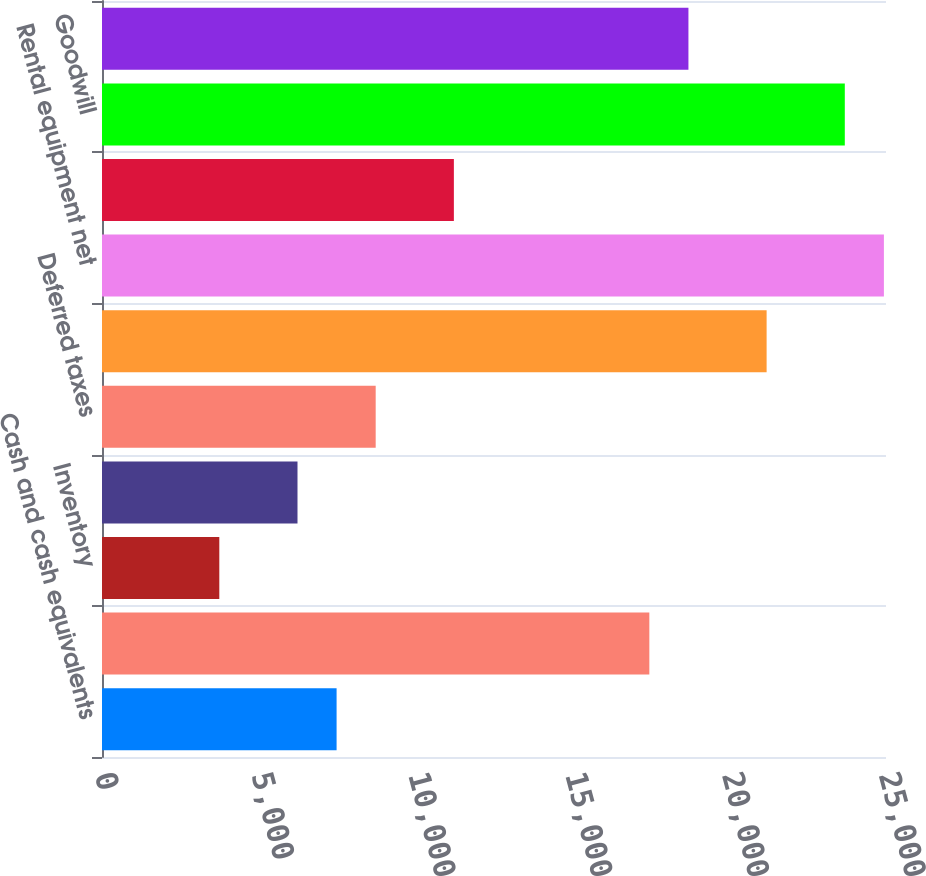Convert chart. <chart><loc_0><loc_0><loc_500><loc_500><bar_chart><fcel>Cash and cash equivalents<fcel>Accounts receivable net of<fcel>Inventory<fcel>Prepaid expenses and other<fcel>Deferred taxes<fcel>Total current assets<fcel>Rental equipment net<fcel>Property and equipment net<fcel>Goodwill<fcel>Other intangible assets net<nl><fcel>7480.6<fcel>17453.4<fcel>3740.8<fcel>6234<fcel>8727.2<fcel>21193.2<fcel>24933<fcel>11220.4<fcel>23686.4<fcel>18700<nl></chart> 